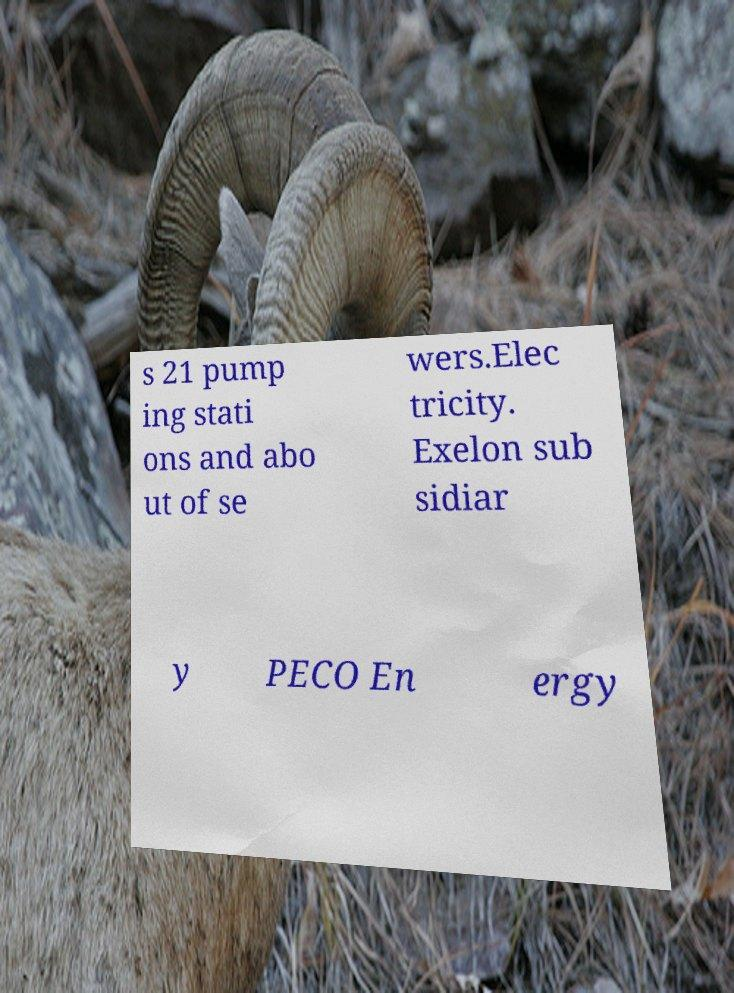Please read and relay the text visible in this image. What does it say? s 21 pump ing stati ons and abo ut of se wers.Elec tricity. Exelon sub sidiar y PECO En ergy 